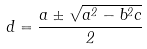<formula> <loc_0><loc_0><loc_500><loc_500>d = \frac { a \pm \sqrt { a ^ { 2 } - b ^ { 2 } c } } { 2 }</formula> 